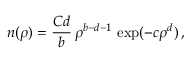<formula> <loc_0><loc_0><loc_500><loc_500>n ( \rho ) = \frac { C d } { b } \, \rho ^ { b - d - 1 } \, \exp ( - c \rho ^ { d } ) \, ,</formula> 